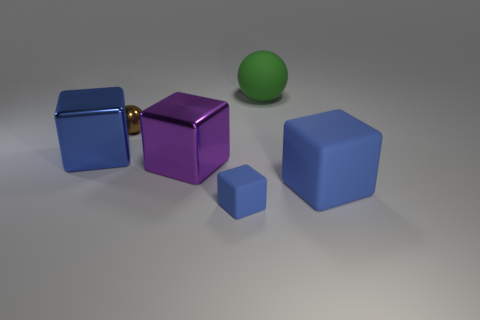Subtract all blue blocks. How many were subtracted if there are1blue blocks left? 2 Add 3 large gray balls. How many objects exist? 9 Subtract all blue cylinders. How many blue cubes are left? 3 Subtract all big purple shiny cubes. How many cubes are left? 3 Subtract 2 cubes. How many cubes are left? 2 Subtract all purple cubes. How many cubes are left? 3 Subtract all blocks. How many objects are left? 2 Subtract all gray cubes. Subtract all purple cylinders. How many cubes are left? 4 Subtract all big green cylinders. Subtract all purple cubes. How many objects are left? 5 Add 5 metallic things. How many metallic things are left? 8 